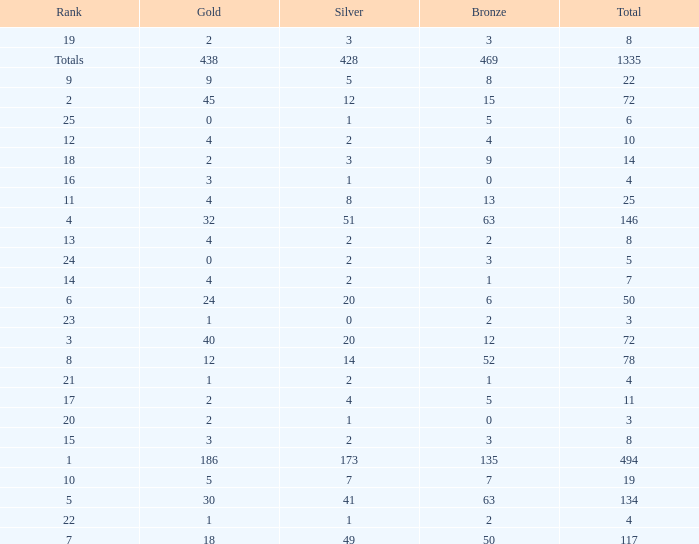What is the total amount of gold medals when there were more than 20 silvers and there were 135 bronze medals? 1.0. 